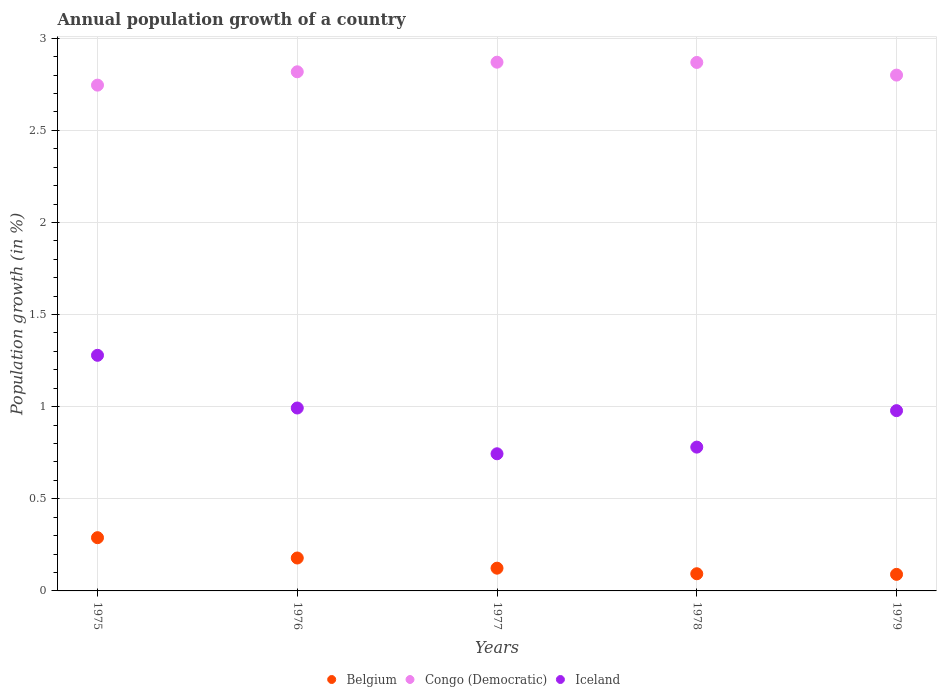Is the number of dotlines equal to the number of legend labels?
Keep it short and to the point. Yes. What is the annual population growth in Belgium in 1976?
Your answer should be compact. 0.18. Across all years, what is the maximum annual population growth in Congo (Democratic)?
Offer a very short reply. 2.87. Across all years, what is the minimum annual population growth in Congo (Democratic)?
Ensure brevity in your answer.  2.75. In which year was the annual population growth in Iceland maximum?
Your answer should be compact. 1975. In which year was the annual population growth in Iceland minimum?
Provide a succinct answer. 1977. What is the total annual population growth in Iceland in the graph?
Ensure brevity in your answer.  4.78. What is the difference between the annual population growth in Belgium in 1977 and that in 1978?
Your response must be concise. 0.03. What is the difference between the annual population growth in Belgium in 1979 and the annual population growth in Iceland in 1975?
Make the answer very short. -1.19. What is the average annual population growth in Iceland per year?
Your answer should be very brief. 0.96. In the year 1977, what is the difference between the annual population growth in Belgium and annual population growth in Congo (Democratic)?
Your answer should be very brief. -2.75. In how many years, is the annual population growth in Iceland greater than 0.30000000000000004 %?
Your response must be concise. 5. What is the ratio of the annual population growth in Belgium in 1977 to that in 1978?
Provide a succinct answer. 1.32. What is the difference between the highest and the second highest annual population growth in Iceland?
Keep it short and to the point. 0.29. What is the difference between the highest and the lowest annual population growth in Iceland?
Your response must be concise. 0.53. In how many years, is the annual population growth in Belgium greater than the average annual population growth in Belgium taken over all years?
Keep it short and to the point. 2. Is the sum of the annual population growth in Congo (Democratic) in 1975 and 1978 greater than the maximum annual population growth in Iceland across all years?
Your answer should be very brief. Yes. Does the annual population growth in Belgium monotonically increase over the years?
Make the answer very short. No. Is the annual population growth in Belgium strictly greater than the annual population growth in Iceland over the years?
Give a very brief answer. No. Does the graph contain any zero values?
Offer a terse response. No. Where does the legend appear in the graph?
Your response must be concise. Bottom center. What is the title of the graph?
Offer a very short reply. Annual population growth of a country. What is the label or title of the X-axis?
Provide a succinct answer. Years. What is the label or title of the Y-axis?
Offer a terse response. Population growth (in %). What is the Population growth (in %) of Belgium in 1975?
Your answer should be compact. 0.29. What is the Population growth (in %) of Congo (Democratic) in 1975?
Give a very brief answer. 2.75. What is the Population growth (in %) of Iceland in 1975?
Your response must be concise. 1.28. What is the Population growth (in %) in Belgium in 1976?
Provide a short and direct response. 0.18. What is the Population growth (in %) in Congo (Democratic) in 1976?
Offer a very short reply. 2.82. What is the Population growth (in %) in Iceland in 1976?
Make the answer very short. 0.99. What is the Population growth (in %) of Belgium in 1977?
Offer a very short reply. 0.12. What is the Population growth (in %) in Congo (Democratic) in 1977?
Your answer should be very brief. 2.87. What is the Population growth (in %) in Iceland in 1977?
Your response must be concise. 0.74. What is the Population growth (in %) in Belgium in 1978?
Give a very brief answer. 0.09. What is the Population growth (in %) of Congo (Democratic) in 1978?
Make the answer very short. 2.87. What is the Population growth (in %) in Iceland in 1978?
Provide a succinct answer. 0.78. What is the Population growth (in %) of Belgium in 1979?
Give a very brief answer. 0.09. What is the Population growth (in %) in Congo (Democratic) in 1979?
Keep it short and to the point. 2.8. What is the Population growth (in %) in Iceland in 1979?
Give a very brief answer. 0.98. Across all years, what is the maximum Population growth (in %) in Belgium?
Offer a terse response. 0.29. Across all years, what is the maximum Population growth (in %) in Congo (Democratic)?
Your answer should be compact. 2.87. Across all years, what is the maximum Population growth (in %) of Iceland?
Your response must be concise. 1.28. Across all years, what is the minimum Population growth (in %) of Belgium?
Ensure brevity in your answer.  0.09. Across all years, what is the minimum Population growth (in %) of Congo (Democratic)?
Offer a terse response. 2.75. Across all years, what is the minimum Population growth (in %) in Iceland?
Your answer should be compact. 0.74. What is the total Population growth (in %) in Belgium in the graph?
Keep it short and to the point. 0.77. What is the total Population growth (in %) in Congo (Democratic) in the graph?
Your answer should be very brief. 14.1. What is the total Population growth (in %) in Iceland in the graph?
Provide a short and direct response. 4.78. What is the difference between the Population growth (in %) in Belgium in 1975 and that in 1976?
Keep it short and to the point. 0.11. What is the difference between the Population growth (in %) in Congo (Democratic) in 1975 and that in 1976?
Make the answer very short. -0.07. What is the difference between the Population growth (in %) in Iceland in 1975 and that in 1976?
Keep it short and to the point. 0.29. What is the difference between the Population growth (in %) in Belgium in 1975 and that in 1977?
Your answer should be very brief. 0.17. What is the difference between the Population growth (in %) of Congo (Democratic) in 1975 and that in 1977?
Your answer should be very brief. -0.12. What is the difference between the Population growth (in %) of Iceland in 1975 and that in 1977?
Ensure brevity in your answer.  0.53. What is the difference between the Population growth (in %) in Belgium in 1975 and that in 1978?
Your response must be concise. 0.2. What is the difference between the Population growth (in %) in Congo (Democratic) in 1975 and that in 1978?
Provide a succinct answer. -0.12. What is the difference between the Population growth (in %) of Iceland in 1975 and that in 1978?
Your answer should be very brief. 0.5. What is the difference between the Population growth (in %) in Belgium in 1975 and that in 1979?
Give a very brief answer. 0.2. What is the difference between the Population growth (in %) of Congo (Democratic) in 1975 and that in 1979?
Your answer should be very brief. -0.05. What is the difference between the Population growth (in %) in Iceland in 1975 and that in 1979?
Offer a very short reply. 0.3. What is the difference between the Population growth (in %) in Belgium in 1976 and that in 1977?
Your answer should be very brief. 0.06. What is the difference between the Population growth (in %) of Congo (Democratic) in 1976 and that in 1977?
Provide a short and direct response. -0.05. What is the difference between the Population growth (in %) of Iceland in 1976 and that in 1977?
Your answer should be very brief. 0.25. What is the difference between the Population growth (in %) of Belgium in 1976 and that in 1978?
Provide a succinct answer. 0.09. What is the difference between the Population growth (in %) in Congo (Democratic) in 1976 and that in 1978?
Offer a very short reply. -0.05. What is the difference between the Population growth (in %) in Iceland in 1976 and that in 1978?
Provide a short and direct response. 0.21. What is the difference between the Population growth (in %) in Belgium in 1976 and that in 1979?
Offer a terse response. 0.09. What is the difference between the Population growth (in %) in Congo (Democratic) in 1976 and that in 1979?
Make the answer very short. 0.02. What is the difference between the Population growth (in %) of Iceland in 1976 and that in 1979?
Provide a short and direct response. 0.01. What is the difference between the Population growth (in %) in Belgium in 1977 and that in 1978?
Your answer should be very brief. 0.03. What is the difference between the Population growth (in %) in Congo (Democratic) in 1977 and that in 1978?
Make the answer very short. 0. What is the difference between the Population growth (in %) in Iceland in 1977 and that in 1978?
Give a very brief answer. -0.04. What is the difference between the Population growth (in %) of Belgium in 1977 and that in 1979?
Provide a short and direct response. 0.03. What is the difference between the Population growth (in %) in Congo (Democratic) in 1977 and that in 1979?
Keep it short and to the point. 0.07. What is the difference between the Population growth (in %) of Iceland in 1977 and that in 1979?
Your response must be concise. -0.23. What is the difference between the Population growth (in %) in Belgium in 1978 and that in 1979?
Give a very brief answer. 0. What is the difference between the Population growth (in %) of Congo (Democratic) in 1978 and that in 1979?
Provide a short and direct response. 0.07. What is the difference between the Population growth (in %) of Iceland in 1978 and that in 1979?
Your response must be concise. -0.2. What is the difference between the Population growth (in %) in Belgium in 1975 and the Population growth (in %) in Congo (Democratic) in 1976?
Provide a short and direct response. -2.53. What is the difference between the Population growth (in %) of Belgium in 1975 and the Population growth (in %) of Iceland in 1976?
Give a very brief answer. -0.7. What is the difference between the Population growth (in %) in Congo (Democratic) in 1975 and the Population growth (in %) in Iceland in 1976?
Give a very brief answer. 1.75. What is the difference between the Population growth (in %) of Belgium in 1975 and the Population growth (in %) of Congo (Democratic) in 1977?
Your response must be concise. -2.58. What is the difference between the Population growth (in %) of Belgium in 1975 and the Population growth (in %) of Iceland in 1977?
Offer a terse response. -0.46. What is the difference between the Population growth (in %) of Congo (Democratic) in 1975 and the Population growth (in %) of Iceland in 1977?
Provide a succinct answer. 2. What is the difference between the Population growth (in %) of Belgium in 1975 and the Population growth (in %) of Congo (Democratic) in 1978?
Your answer should be very brief. -2.58. What is the difference between the Population growth (in %) of Belgium in 1975 and the Population growth (in %) of Iceland in 1978?
Your answer should be very brief. -0.49. What is the difference between the Population growth (in %) of Congo (Democratic) in 1975 and the Population growth (in %) of Iceland in 1978?
Keep it short and to the point. 1.96. What is the difference between the Population growth (in %) in Belgium in 1975 and the Population growth (in %) in Congo (Democratic) in 1979?
Your answer should be very brief. -2.51. What is the difference between the Population growth (in %) in Belgium in 1975 and the Population growth (in %) in Iceland in 1979?
Your answer should be compact. -0.69. What is the difference between the Population growth (in %) of Congo (Democratic) in 1975 and the Population growth (in %) of Iceland in 1979?
Provide a short and direct response. 1.77. What is the difference between the Population growth (in %) of Belgium in 1976 and the Population growth (in %) of Congo (Democratic) in 1977?
Make the answer very short. -2.69. What is the difference between the Population growth (in %) of Belgium in 1976 and the Population growth (in %) of Iceland in 1977?
Keep it short and to the point. -0.57. What is the difference between the Population growth (in %) of Congo (Democratic) in 1976 and the Population growth (in %) of Iceland in 1977?
Keep it short and to the point. 2.07. What is the difference between the Population growth (in %) in Belgium in 1976 and the Population growth (in %) in Congo (Democratic) in 1978?
Your response must be concise. -2.69. What is the difference between the Population growth (in %) in Belgium in 1976 and the Population growth (in %) in Iceland in 1978?
Provide a succinct answer. -0.6. What is the difference between the Population growth (in %) of Congo (Democratic) in 1976 and the Population growth (in %) of Iceland in 1978?
Offer a terse response. 2.04. What is the difference between the Population growth (in %) of Belgium in 1976 and the Population growth (in %) of Congo (Democratic) in 1979?
Provide a short and direct response. -2.62. What is the difference between the Population growth (in %) in Belgium in 1976 and the Population growth (in %) in Iceland in 1979?
Give a very brief answer. -0.8. What is the difference between the Population growth (in %) of Congo (Democratic) in 1976 and the Population growth (in %) of Iceland in 1979?
Offer a terse response. 1.84. What is the difference between the Population growth (in %) of Belgium in 1977 and the Population growth (in %) of Congo (Democratic) in 1978?
Give a very brief answer. -2.75. What is the difference between the Population growth (in %) in Belgium in 1977 and the Population growth (in %) in Iceland in 1978?
Offer a very short reply. -0.66. What is the difference between the Population growth (in %) in Congo (Democratic) in 1977 and the Population growth (in %) in Iceland in 1978?
Your response must be concise. 2.09. What is the difference between the Population growth (in %) in Belgium in 1977 and the Population growth (in %) in Congo (Democratic) in 1979?
Your response must be concise. -2.68. What is the difference between the Population growth (in %) in Belgium in 1977 and the Population growth (in %) in Iceland in 1979?
Offer a very short reply. -0.85. What is the difference between the Population growth (in %) in Congo (Democratic) in 1977 and the Population growth (in %) in Iceland in 1979?
Offer a very short reply. 1.89. What is the difference between the Population growth (in %) in Belgium in 1978 and the Population growth (in %) in Congo (Democratic) in 1979?
Provide a short and direct response. -2.71. What is the difference between the Population growth (in %) of Belgium in 1978 and the Population growth (in %) of Iceland in 1979?
Ensure brevity in your answer.  -0.89. What is the difference between the Population growth (in %) in Congo (Democratic) in 1978 and the Population growth (in %) in Iceland in 1979?
Offer a terse response. 1.89. What is the average Population growth (in %) of Belgium per year?
Your answer should be very brief. 0.15. What is the average Population growth (in %) of Congo (Democratic) per year?
Offer a very short reply. 2.82. What is the average Population growth (in %) in Iceland per year?
Provide a short and direct response. 0.95. In the year 1975, what is the difference between the Population growth (in %) in Belgium and Population growth (in %) in Congo (Democratic)?
Ensure brevity in your answer.  -2.46. In the year 1975, what is the difference between the Population growth (in %) of Belgium and Population growth (in %) of Iceland?
Your answer should be very brief. -0.99. In the year 1975, what is the difference between the Population growth (in %) in Congo (Democratic) and Population growth (in %) in Iceland?
Ensure brevity in your answer.  1.47. In the year 1976, what is the difference between the Population growth (in %) of Belgium and Population growth (in %) of Congo (Democratic)?
Your answer should be compact. -2.64. In the year 1976, what is the difference between the Population growth (in %) in Belgium and Population growth (in %) in Iceland?
Give a very brief answer. -0.81. In the year 1976, what is the difference between the Population growth (in %) of Congo (Democratic) and Population growth (in %) of Iceland?
Give a very brief answer. 1.82. In the year 1977, what is the difference between the Population growth (in %) of Belgium and Population growth (in %) of Congo (Democratic)?
Your answer should be compact. -2.75. In the year 1977, what is the difference between the Population growth (in %) in Belgium and Population growth (in %) in Iceland?
Provide a succinct answer. -0.62. In the year 1977, what is the difference between the Population growth (in %) of Congo (Democratic) and Population growth (in %) of Iceland?
Offer a terse response. 2.13. In the year 1978, what is the difference between the Population growth (in %) of Belgium and Population growth (in %) of Congo (Democratic)?
Give a very brief answer. -2.78. In the year 1978, what is the difference between the Population growth (in %) of Belgium and Population growth (in %) of Iceland?
Offer a terse response. -0.69. In the year 1978, what is the difference between the Population growth (in %) of Congo (Democratic) and Population growth (in %) of Iceland?
Ensure brevity in your answer.  2.09. In the year 1979, what is the difference between the Population growth (in %) in Belgium and Population growth (in %) in Congo (Democratic)?
Give a very brief answer. -2.71. In the year 1979, what is the difference between the Population growth (in %) in Belgium and Population growth (in %) in Iceland?
Provide a succinct answer. -0.89. In the year 1979, what is the difference between the Population growth (in %) of Congo (Democratic) and Population growth (in %) of Iceland?
Provide a succinct answer. 1.82. What is the ratio of the Population growth (in %) in Belgium in 1975 to that in 1976?
Your response must be concise. 1.62. What is the ratio of the Population growth (in %) in Congo (Democratic) in 1975 to that in 1976?
Offer a very short reply. 0.97. What is the ratio of the Population growth (in %) in Iceland in 1975 to that in 1976?
Ensure brevity in your answer.  1.29. What is the ratio of the Population growth (in %) of Belgium in 1975 to that in 1977?
Provide a short and direct response. 2.34. What is the ratio of the Population growth (in %) of Congo (Democratic) in 1975 to that in 1977?
Keep it short and to the point. 0.96. What is the ratio of the Population growth (in %) in Iceland in 1975 to that in 1977?
Make the answer very short. 1.72. What is the ratio of the Population growth (in %) of Belgium in 1975 to that in 1978?
Your response must be concise. 3.1. What is the ratio of the Population growth (in %) of Congo (Democratic) in 1975 to that in 1978?
Your answer should be very brief. 0.96. What is the ratio of the Population growth (in %) in Iceland in 1975 to that in 1978?
Give a very brief answer. 1.64. What is the ratio of the Population growth (in %) of Belgium in 1975 to that in 1979?
Offer a terse response. 3.22. What is the ratio of the Population growth (in %) of Congo (Democratic) in 1975 to that in 1979?
Make the answer very short. 0.98. What is the ratio of the Population growth (in %) in Iceland in 1975 to that in 1979?
Ensure brevity in your answer.  1.31. What is the ratio of the Population growth (in %) of Belgium in 1976 to that in 1977?
Your answer should be compact. 1.45. What is the ratio of the Population growth (in %) in Congo (Democratic) in 1976 to that in 1977?
Give a very brief answer. 0.98. What is the ratio of the Population growth (in %) in Iceland in 1976 to that in 1977?
Keep it short and to the point. 1.33. What is the ratio of the Population growth (in %) of Belgium in 1976 to that in 1978?
Your answer should be compact. 1.92. What is the ratio of the Population growth (in %) in Congo (Democratic) in 1976 to that in 1978?
Your response must be concise. 0.98. What is the ratio of the Population growth (in %) of Iceland in 1976 to that in 1978?
Your response must be concise. 1.27. What is the ratio of the Population growth (in %) of Belgium in 1976 to that in 1979?
Make the answer very short. 1.99. What is the ratio of the Population growth (in %) of Congo (Democratic) in 1976 to that in 1979?
Your answer should be compact. 1.01. What is the ratio of the Population growth (in %) in Iceland in 1976 to that in 1979?
Ensure brevity in your answer.  1.01. What is the ratio of the Population growth (in %) of Belgium in 1977 to that in 1978?
Keep it short and to the point. 1.32. What is the ratio of the Population growth (in %) of Congo (Democratic) in 1977 to that in 1978?
Keep it short and to the point. 1. What is the ratio of the Population growth (in %) in Iceland in 1977 to that in 1978?
Your answer should be compact. 0.95. What is the ratio of the Population growth (in %) in Belgium in 1977 to that in 1979?
Make the answer very short. 1.37. What is the ratio of the Population growth (in %) in Iceland in 1977 to that in 1979?
Offer a terse response. 0.76. What is the ratio of the Population growth (in %) of Belgium in 1978 to that in 1979?
Your response must be concise. 1.04. What is the ratio of the Population growth (in %) of Congo (Democratic) in 1978 to that in 1979?
Your response must be concise. 1.02. What is the ratio of the Population growth (in %) in Iceland in 1978 to that in 1979?
Give a very brief answer. 0.8. What is the difference between the highest and the second highest Population growth (in %) of Belgium?
Provide a succinct answer. 0.11. What is the difference between the highest and the second highest Population growth (in %) in Congo (Democratic)?
Give a very brief answer. 0. What is the difference between the highest and the second highest Population growth (in %) in Iceland?
Offer a very short reply. 0.29. What is the difference between the highest and the lowest Population growth (in %) in Belgium?
Your answer should be compact. 0.2. What is the difference between the highest and the lowest Population growth (in %) in Congo (Democratic)?
Provide a short and direct response. 0.12. What is the difference between the highest and the lowest Population growth (in %) in Iceland?
Offer a terse response. 0.53. 